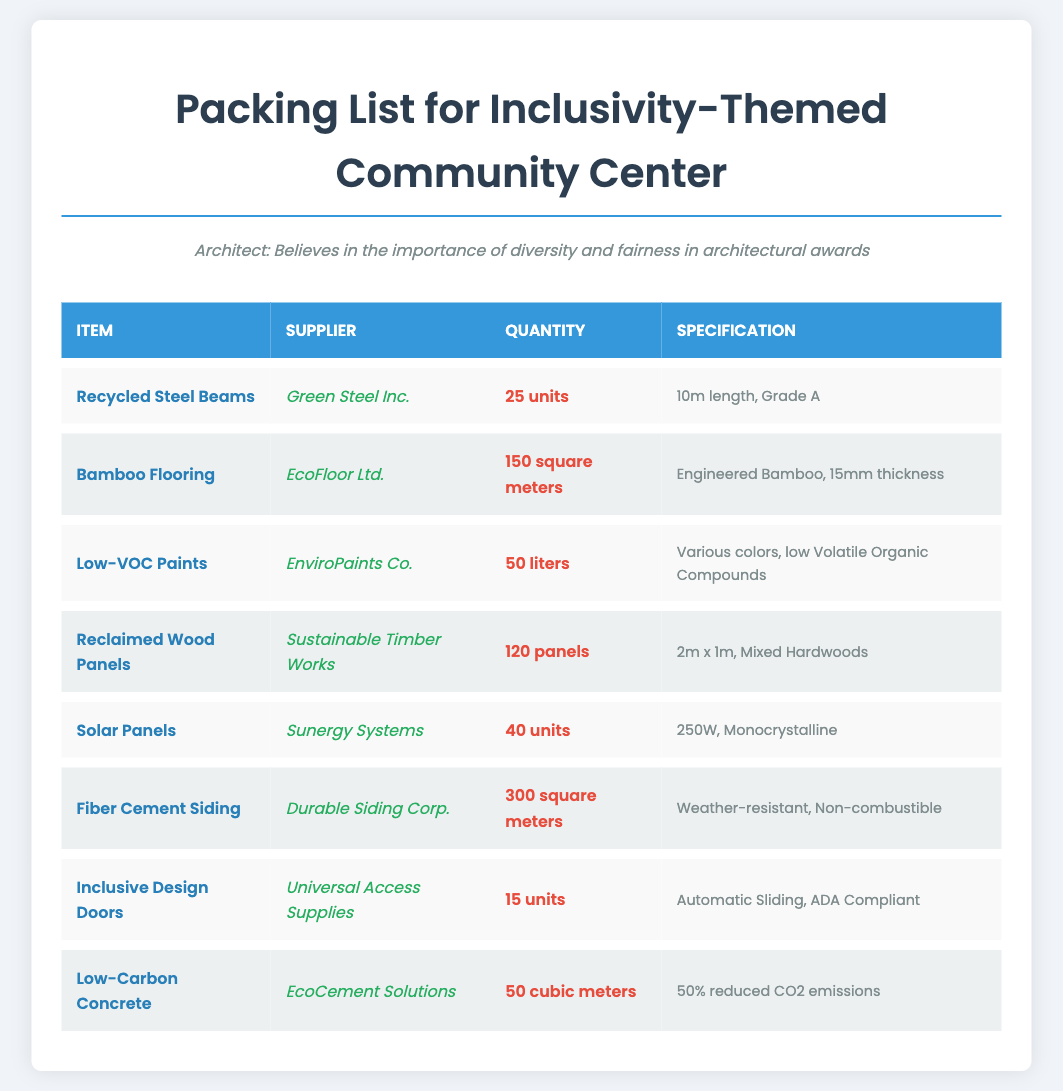What is the supplier of the Recycled Steel Beams? The supplier listed for the Recycled Steel Beams is Green Steel Inc.
Answer: Green Steel Inc How many units of Low-Carbon Concrete are specified? The document specifies 50 cubic meters of Low-Carbon Concrete.
Answer: 50 cubic meters What type of flooring is included in the packing list? The packing list includes Bamboo Flooring.
Answer: Bamboo Flooring How many Inclusive Design Doors are being shipped? The number of Inclusive Design Doors being shipped is 15 units.
Answer: 15 units What is the specification thickness of the Bamboo Flooring? The specification for the Bamboo Flooring is 15mm thickness.
Answer: 15mm thickness Which supplier provides the Solar Panels? The supplier of the Solar Panels is Sunergy Systems.
Answer: Sunergy Systems What are the dimensions of the Reclaimed Wood Panels? The dimensions of the Reclaimed Wood Panels are 2m x 1m.
Answer: 2m x 1m How many liters of Low-VOC Paints are included in the shipment? The shipment includes 50 liters of Low-VOC Paints.
Answer: 50 liters What is the total quantity of Fiber Cement Siding specified? The total quantity of Fiber Cement Siding specified is 300 square meters.
Answer: 300 square meters 